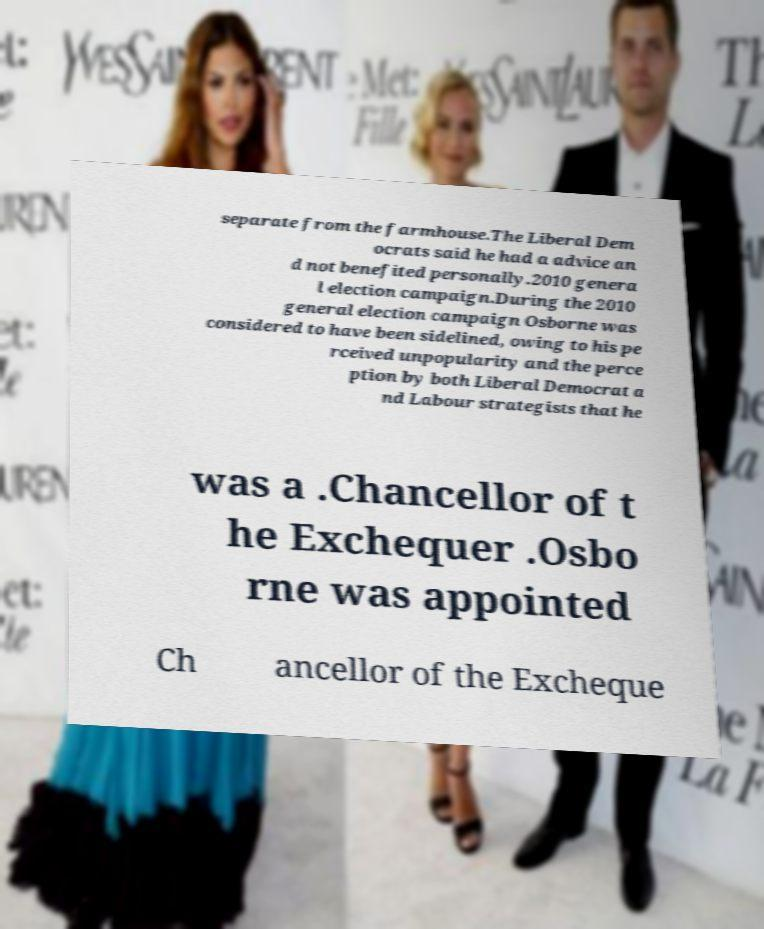Can you read and provide the text displayed in the image?This photo seems to have some interesting text. Can you extract and type it out for me? separate from the farmhouse.The Liberal Dem ocrats said he had a advice an d not benefited personally.2010 genera l election campaign.During the 2010 general election campaign Osborne was considered to have been sidelined, owing to his pe rceived unpopularity and the perce ption by both Liberal Democrat a nd Labour strategists that he was a .Chancellor of t he Exchequer .Osbo rne was appointed Ch ancellor of the Excheque 